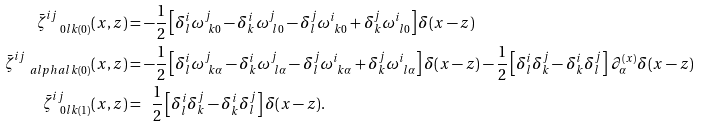Convert formula to latex. <formula><loc_0><loc_0><loc_500><loc_500>\bar { \zeta } ^ { i j } _ { \ \ 0 l k ( 0 ) } ( x , z ) & = - \frac { 1 } { 2 } \left [ \delta ^ { i } _ { l } \omega ^ { j } _ { \ k 0 } - \delta ^ { i } _ { k } \omega ^ { j } _ { \ l 0 } - \delta ^ { j } _ { l } \omega ^ { i } _ { \ k 0 } + \delta ^ { j } _ { k } \omega ^ { i } _ { \ l 0 } \right ] \delta ( { x } - { z } ) \\ \bar { \zeta } ^ { i j } _ { \quad a l p h a l k ( 0 ) } ( x , z ) & = - \frac { 1 } { 2 } \left [ \delta ^ { i } _ { l } \omega ^ { j } _ { \ k \alpha } - \delta ^ { i } _ { k } \omega ^ { j } _ { \ l \alpha } - \delta ^ { j } _ { l } \omega ^ { i } _ { \ k \alpha } + \delta ^ { j } _ { k } \omega ^ { i } _ { \ l \alpha } \right ] \delta ( { x } - { z } ) - \frac { 1 } { 2 } \left [ \delta ^ { i } _ { l } \delta ^ { j } _ { k } - \delta ^ { i } _ { k } \delta ^ { j } _ { l } \right ] \, \partial _ { \alpha } ^ { ( x ) } \delta ( { x } - { z } ) \\ \bar { \zeta } ^ { i j } _ { \ \ 0 l k ( 1 ) } ( x , z ) & = { \ \ } \frac { 1 } { 2 } \left [ \delta ^ { i } _ { l } \delta ^ { j } _ { k } - \delta ^ { i } _ { k } \delta ^ { j } _ { l } \right ] \delta ( { x } - { z } ) . \\</formula> 